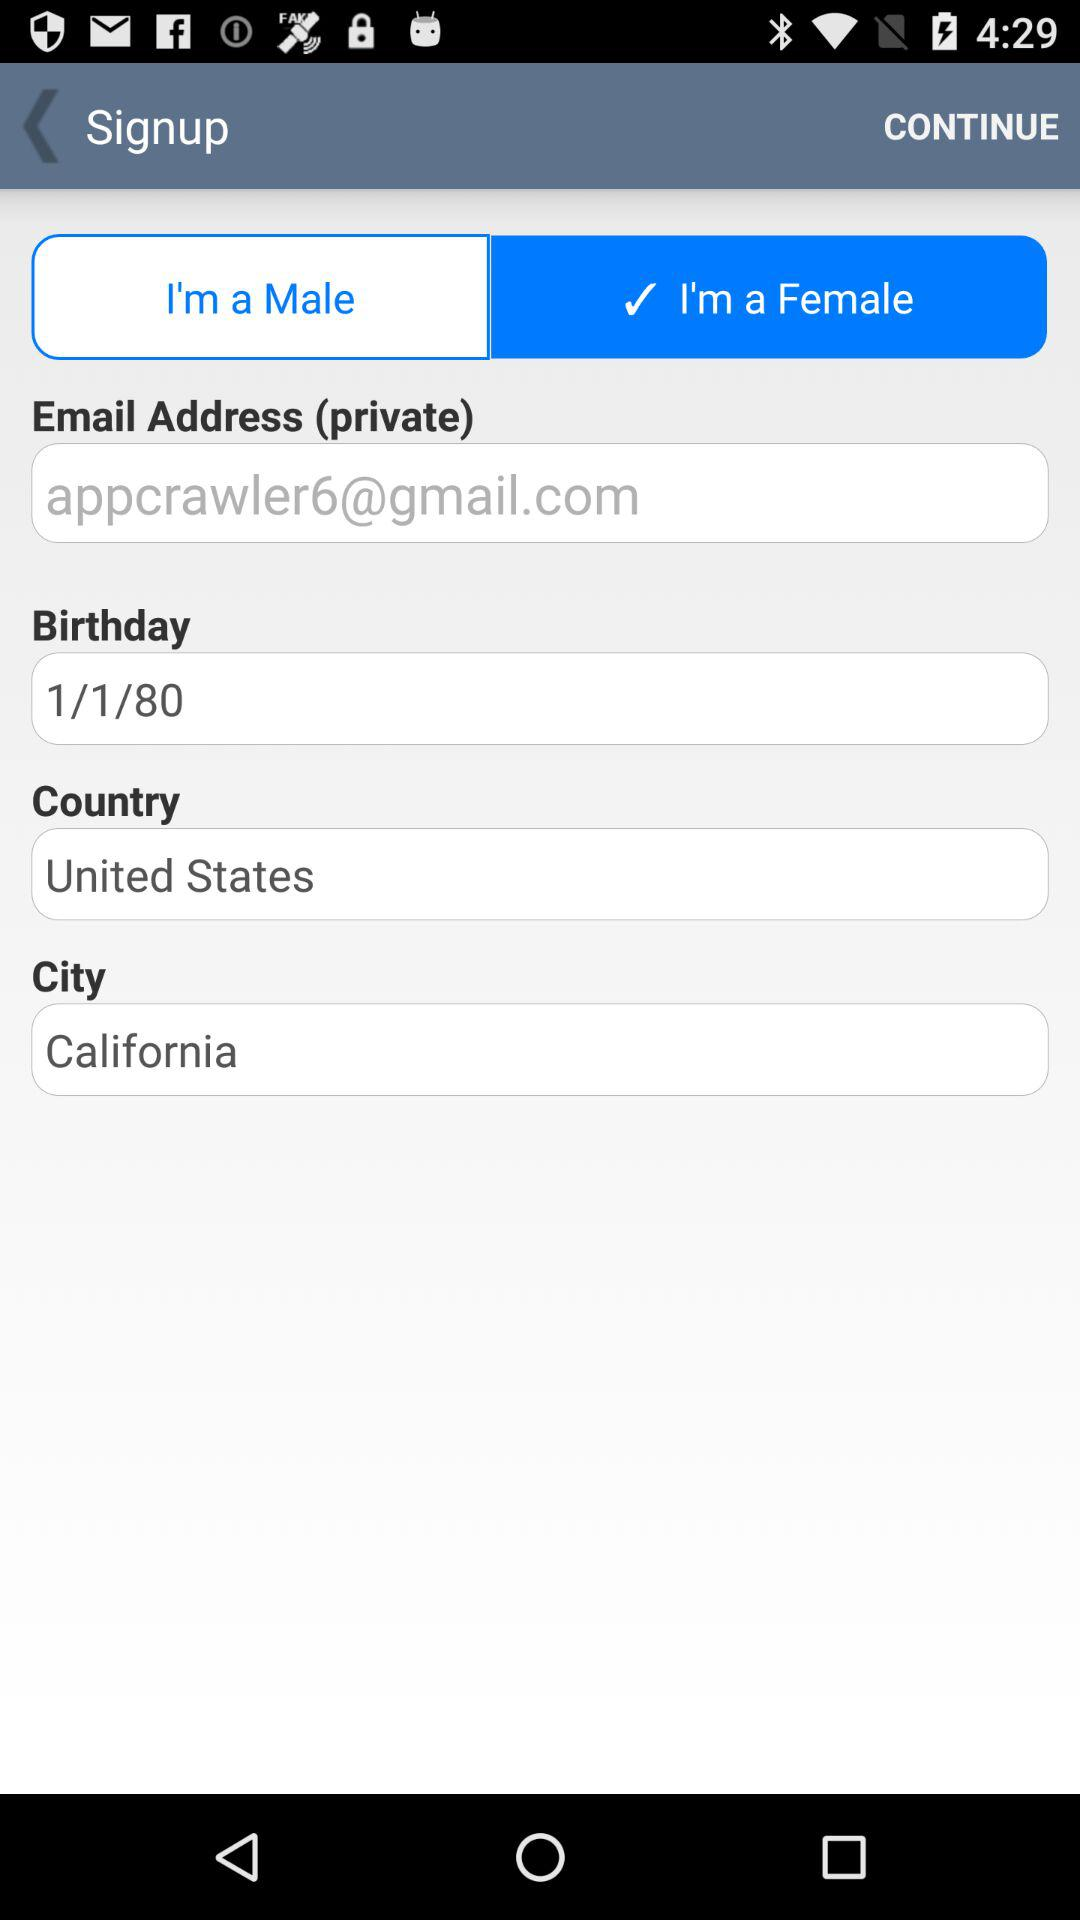What is the email address? The email address is appcrawler6@gmail.com. 